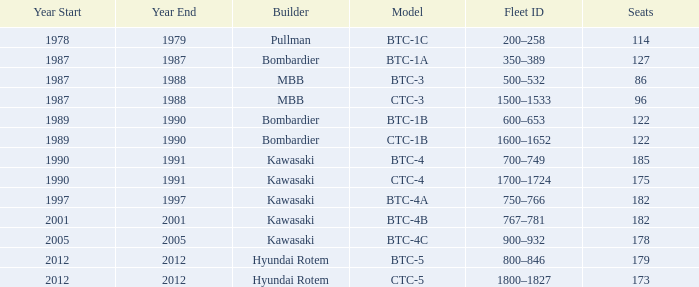In what year was the ctc-3 model built? 1987–88. 